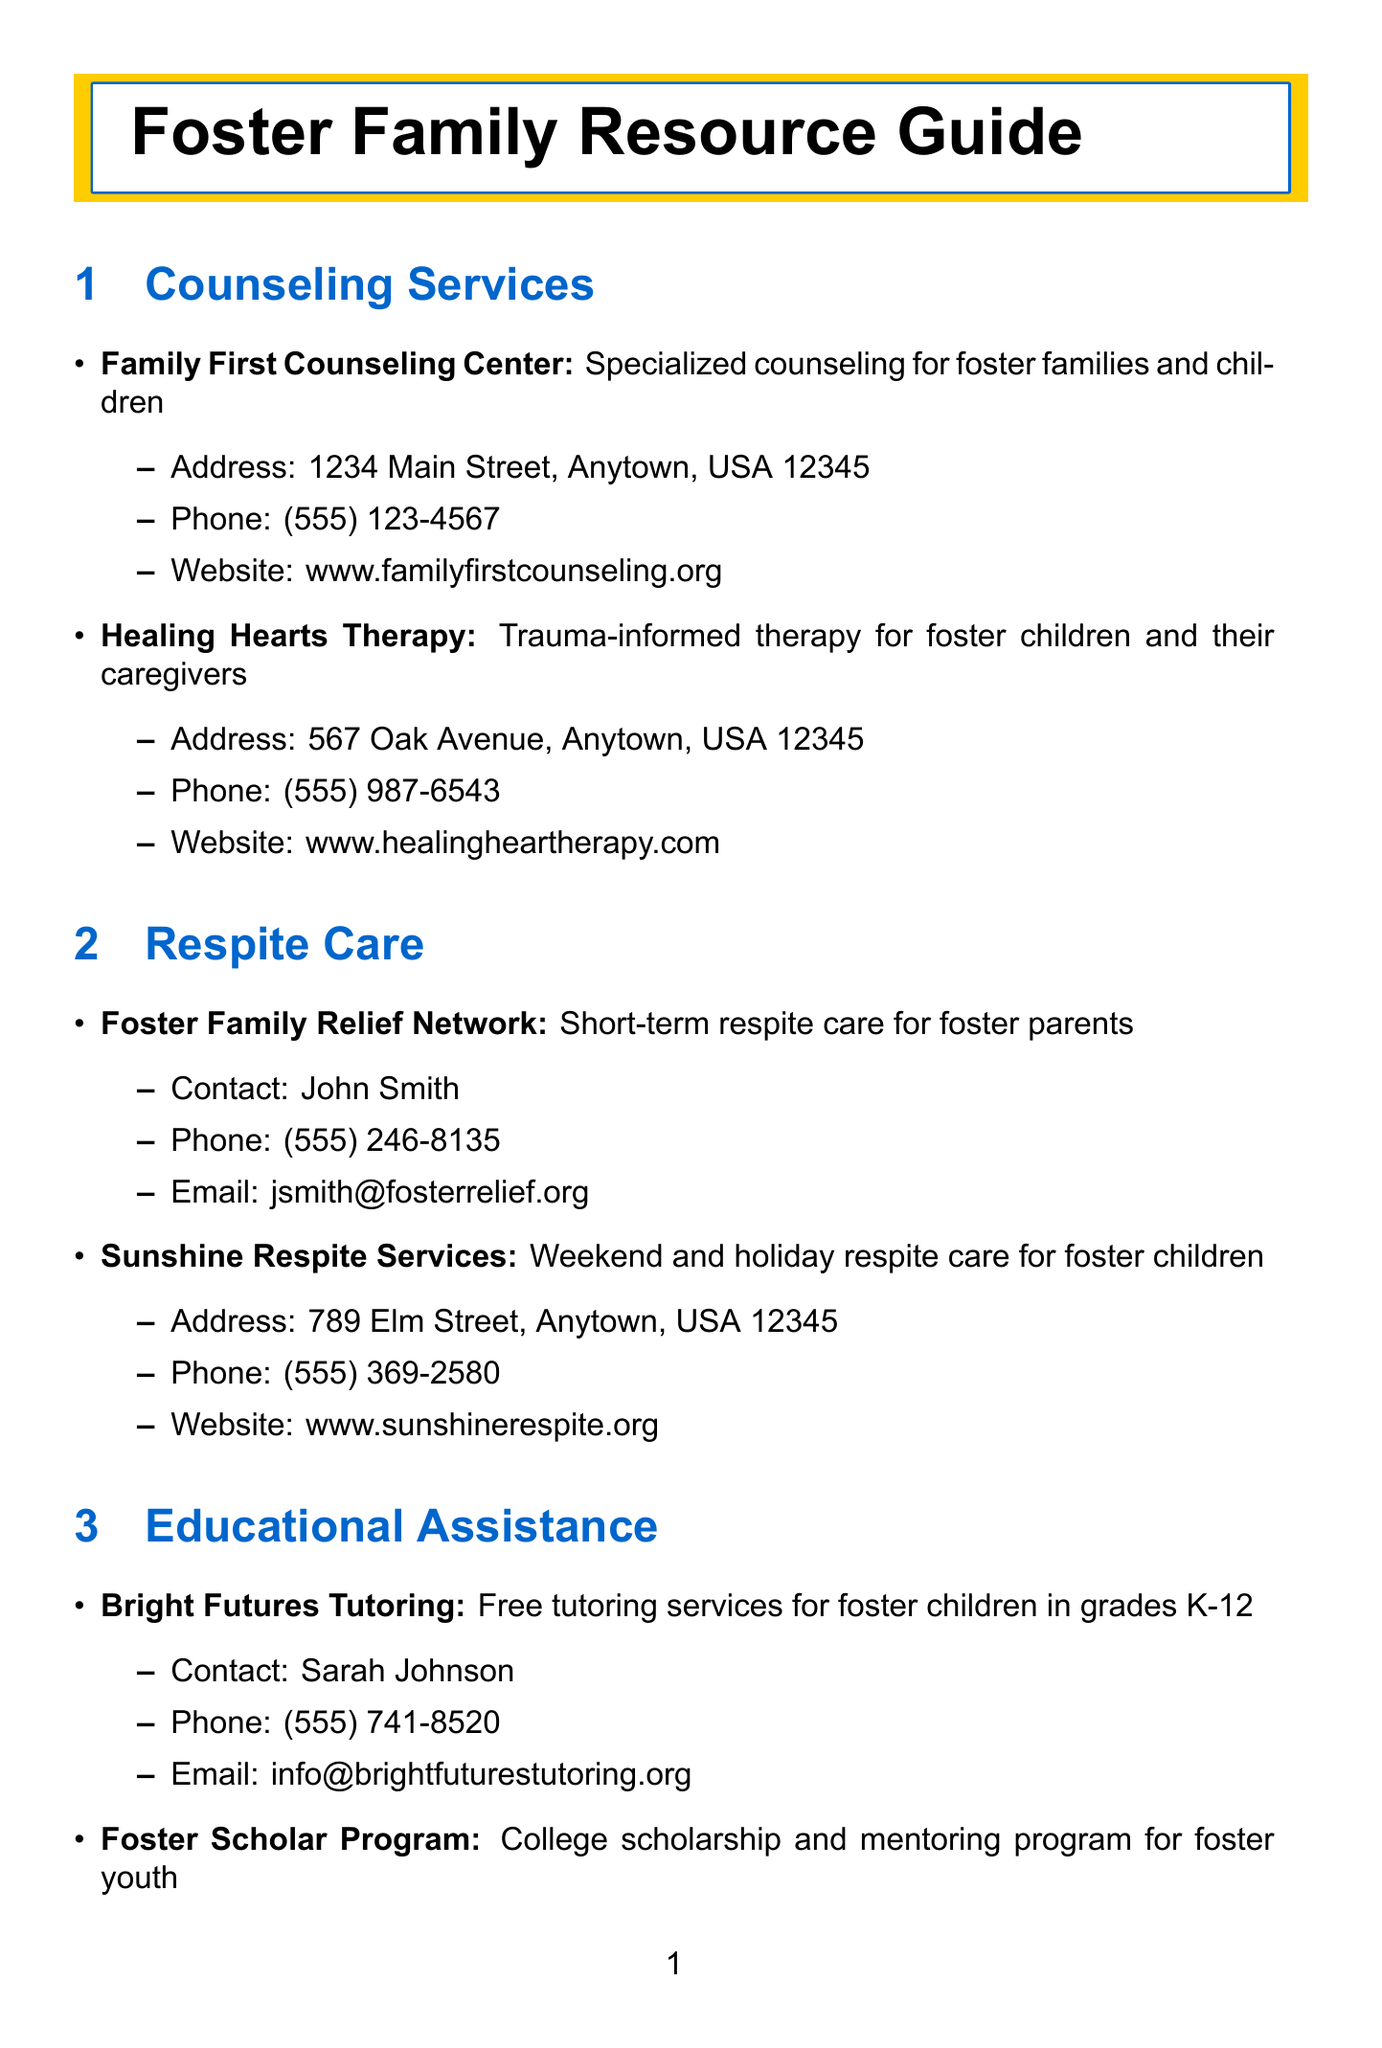What is the address of Family First Counseling Center? The address is listed directly under the counseling service.
Answer: 1234 Main Street, Anytown, USA 12345 Who do I contact for the Foster Family Relief Network? The contact name is provided in the respite care section for this service.
Answer: John Smith What type of therapy does Healing Hearts Therapy provide? The description in the counseling services section elaborates on the specific focus of the therapy offered.
Answer: Trauma-informed therapy Which organization offers free tutoring services for foster children? The educational assistance section clearly states the name of the organization providing these services.
Answer: Bright Futures Tutoring Where is the Foster Parent Alliance support group located? The location is specified directly following the description of the support group in the document.
Answer: Community Center, 456 Maple Drive, Anytown, USA 12345 What type of financial assistance does the Foster Family Foundation provide? The description under financial assistance explicitly states the type of service offered.
Answer: Emergency financial assistance How can one access pro bono legal services for foster families? The specific organization providing these services is outlined in the legal assistance section.
Answer: Foster Care Legal Aid What is the main contact email for Bright Futures Tutoring? The email address is listed under the contacts for this educational assistance program.
Answer: info@brightfuturestutoring.org 